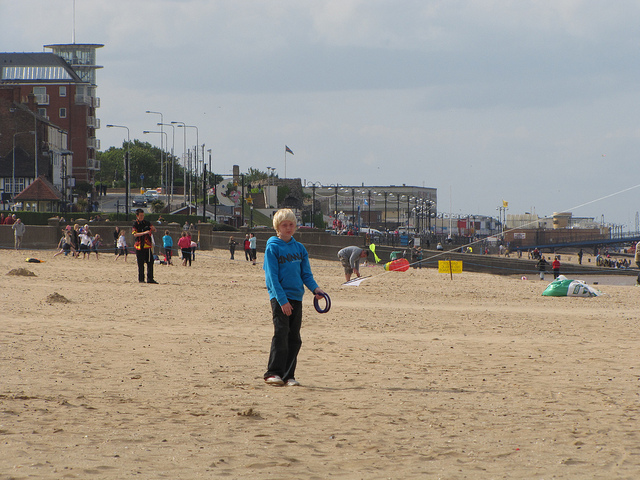<image>What is the color of the umbrella? There is no umbrella in the image. However, it can be seen as brown or red. What pattern is on the person in the foregrounds blue shirt? I don't know what pattern is on the person in the foreground's blue shirt. The pattern might be stripes, solid, words, or there may be no pattern at all. What is the color of the umbrella? There is no umbrella in the image. What pattern is on the person in the foregrounds blue shirt? I am not sure what pattern is on the person's blue shirt in the foreground. It can be seen as stripe, solid, or none. 